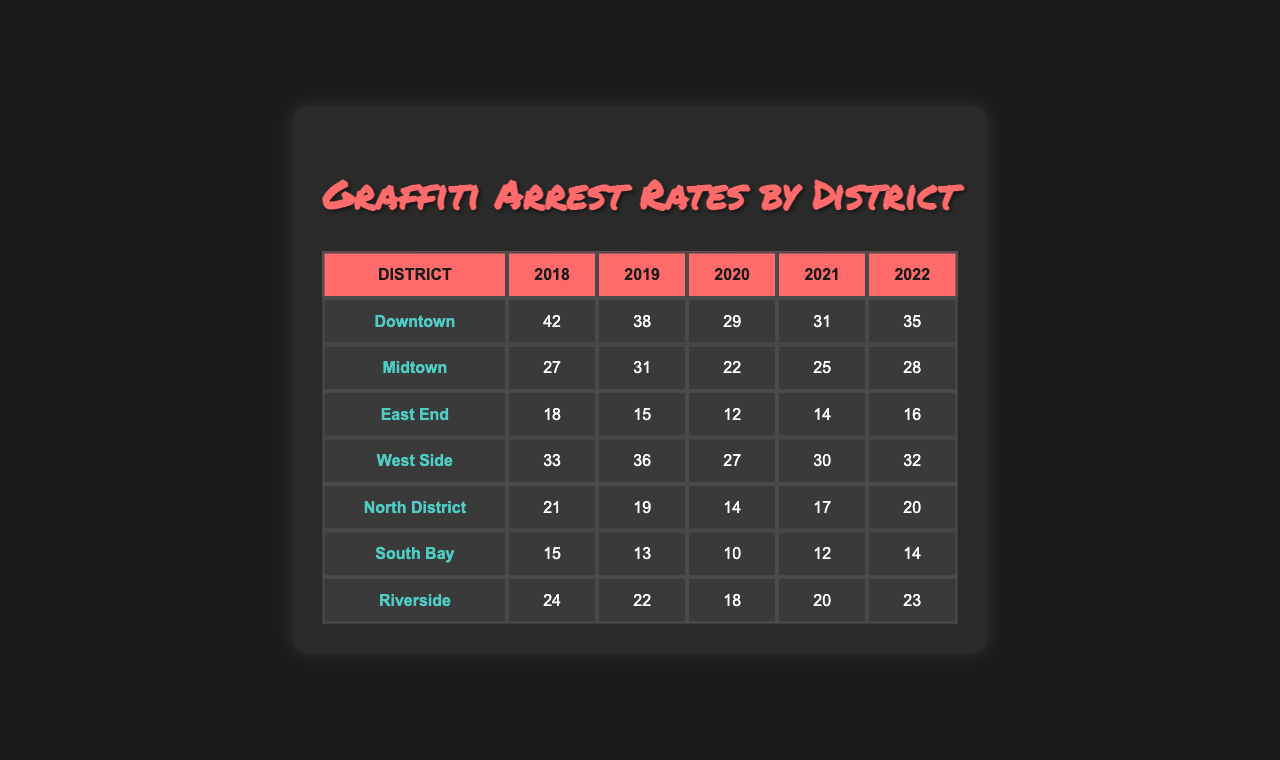What is the total number of arrests for graffiti-related offenses in Downtown for 2018? In the table, the number of arrests in Downtown for 2018 is directly listed as 42.
Answer: 42 What year had the highest number of arrests in Midtown? By examining the arrests in Midtown, we see the values for each year: 27, 31, 22, 25, and 28. The highest value is 31, which occurred in 2019.
Answer: 2019 How many arrests were recorded in the East End in 2020 compared to 2019? In the East End, there were 15 arrests in 2019 and 12 arrests in 2020. The difference is calculated as 15 - 12 = 3.
Answer: 3 Which district had the lowest number of graffiti-related arrests in 2021? For 2021, the arrest numbers are as follows: Downtown 31, Midtown 25, East End 14, West Side 30, North District 17, South Bay 12, Riverside 20. The lowest number is 12, from South Bay.
Answer: South Bay What is the average number of arrests over the years for the North District? The North District arrests are 21, 19, 14, 17, and 20. To find the average, we sum these values: 21 + 19 + 14 + 17 + 20 = 91. Then divide by the number of years (5), so 91 / 5 = 18.2.
Answer: 18.2 Did the total arrests in the West Side from 2018 to 2022 exceed 150? Summing the West Side arrests: 33 (2018) + 36 (2019) + 27 (2020) + 30 (2021) + 32 (2022) equals 158. Since 158 is greater than 150, the answer is yes.
Answer: Yes What was the trend in total arrests from 2018 to 2022 in the Riverside district? For Riverside the totals are: 24 (2018), 22 (2019), 18 (2020), 20 (2021), 23 (2022). Adding these gives us the total arrests: 24 + 22 + 18 + 20 + 23 = 107. Looking at individual years shows a decline from 2018 to 2020, followed by an increase in 2021 and 2022.
Answer: Decline then increase Which district had the highest increase in arrests from 2018 to 2022? Comparing the year-over-year changes across districts, for Downtown: 42 (2018) to 35 (2022) is a decrease of 7; Midtown: 27 to 28 is an increase of 1; East End: 18 to 16 is a decrease of 2; West Side: 33 to 32 is a decrease of 1; North District: 21 to 20 is a decrease of 1; South Bay: 15 to 14 is a decrease of 1; Riverside: 24 to 23 is a decrease of 1. The highest increase is in Midtown with a change of +1.
Answer: Midtown What was the median number of arrests in 2019 across all districts? First, list the arrests for 2019: Downtown 38, Midtown 31, East End 15, West Side 36, North District 19, South Bay 13, Riverside 22. Sorting these gives: 13, 15, 19, 22, 31, 36, 38. The median (middle value of the sorted list) is 22.
Answer: 22 